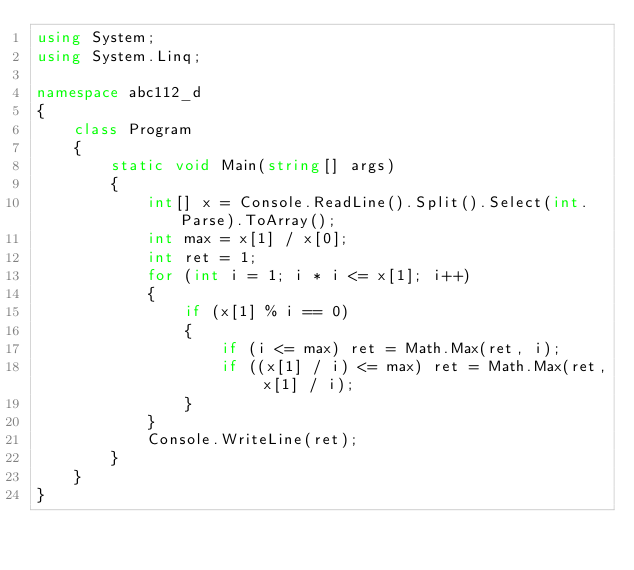Convert code to text. <code><loc_0><loc_0><loc_500><loc_500><_C#_>using System;
using System.Linq;

namespace abc112_d
{
	class Program
	{
		static void Main(string[] args)
		{
			int[] x = Console.ReadLine().Split().Select(int.Parse).ToArray();
			int max = x[1] / x[0];
			int ret = 1;
			for (int i = 1; i * i <= x[1]; i++)
			{
				if (x[1] % i == 0)
				{
					if (i <= max) ret = Math.Max(ret, i);
					if ((x[1] / i) <= max) ret = Math.Max(ret, x[1] / i);
				}
			}
			Console.WriteLine(ret);
		}
	}
}</code> 